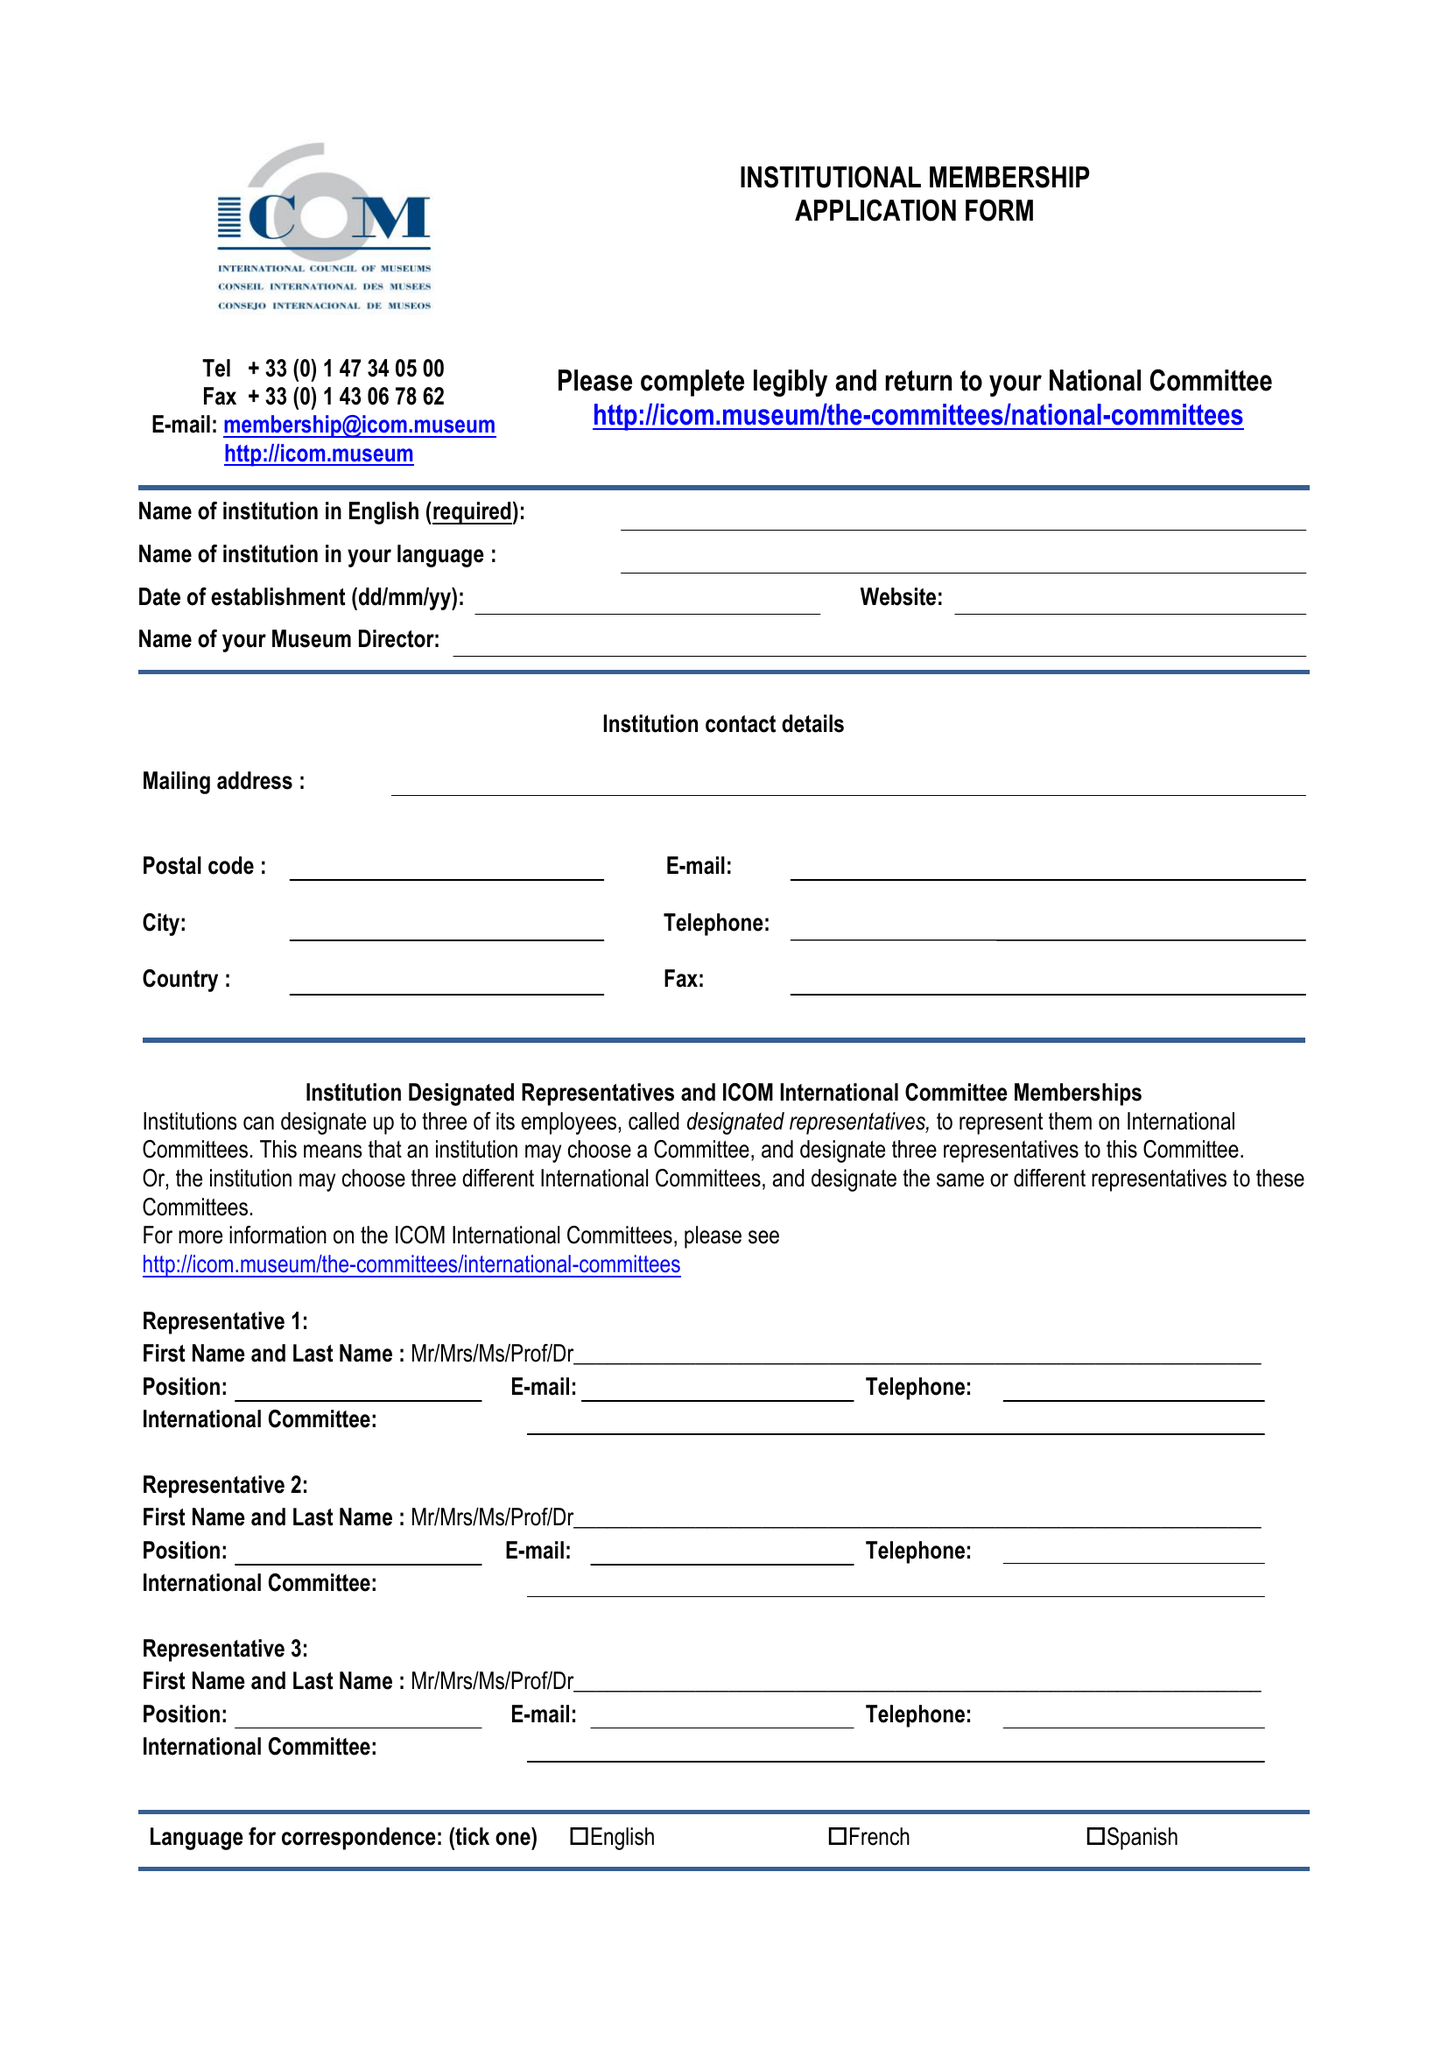What is the value for the address__postcode?
Answer the question using a single word or phrase. EC1V 2NX 